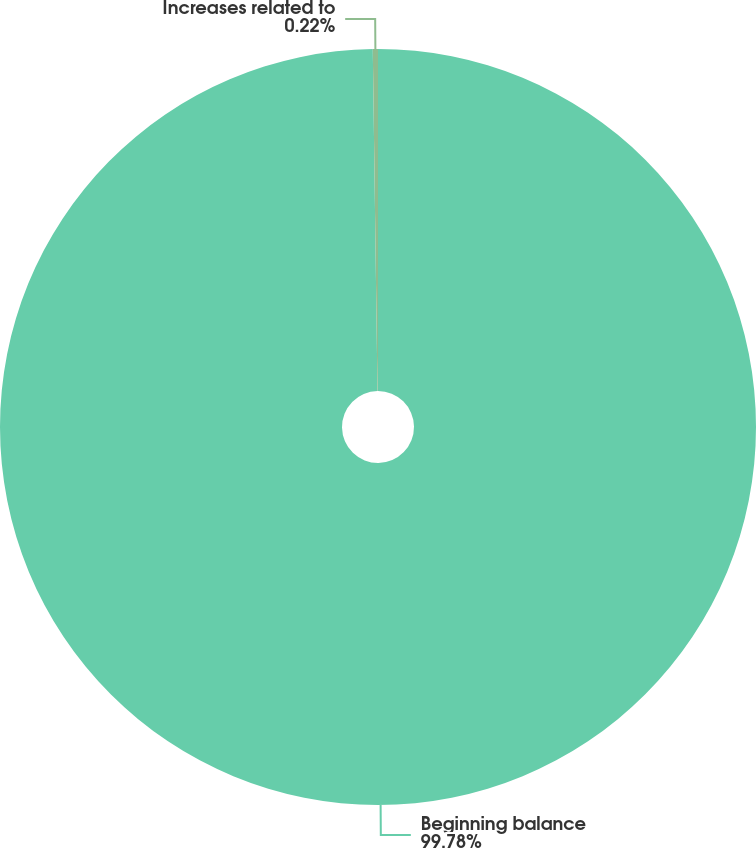<chart> <loc_0><loc_0><loc_500><loc_500><pie_chart><fcel>Beginning balance<fcel>Increases related to<nl><fcel>99.78%<fcel>0.22%<nl></chart> 